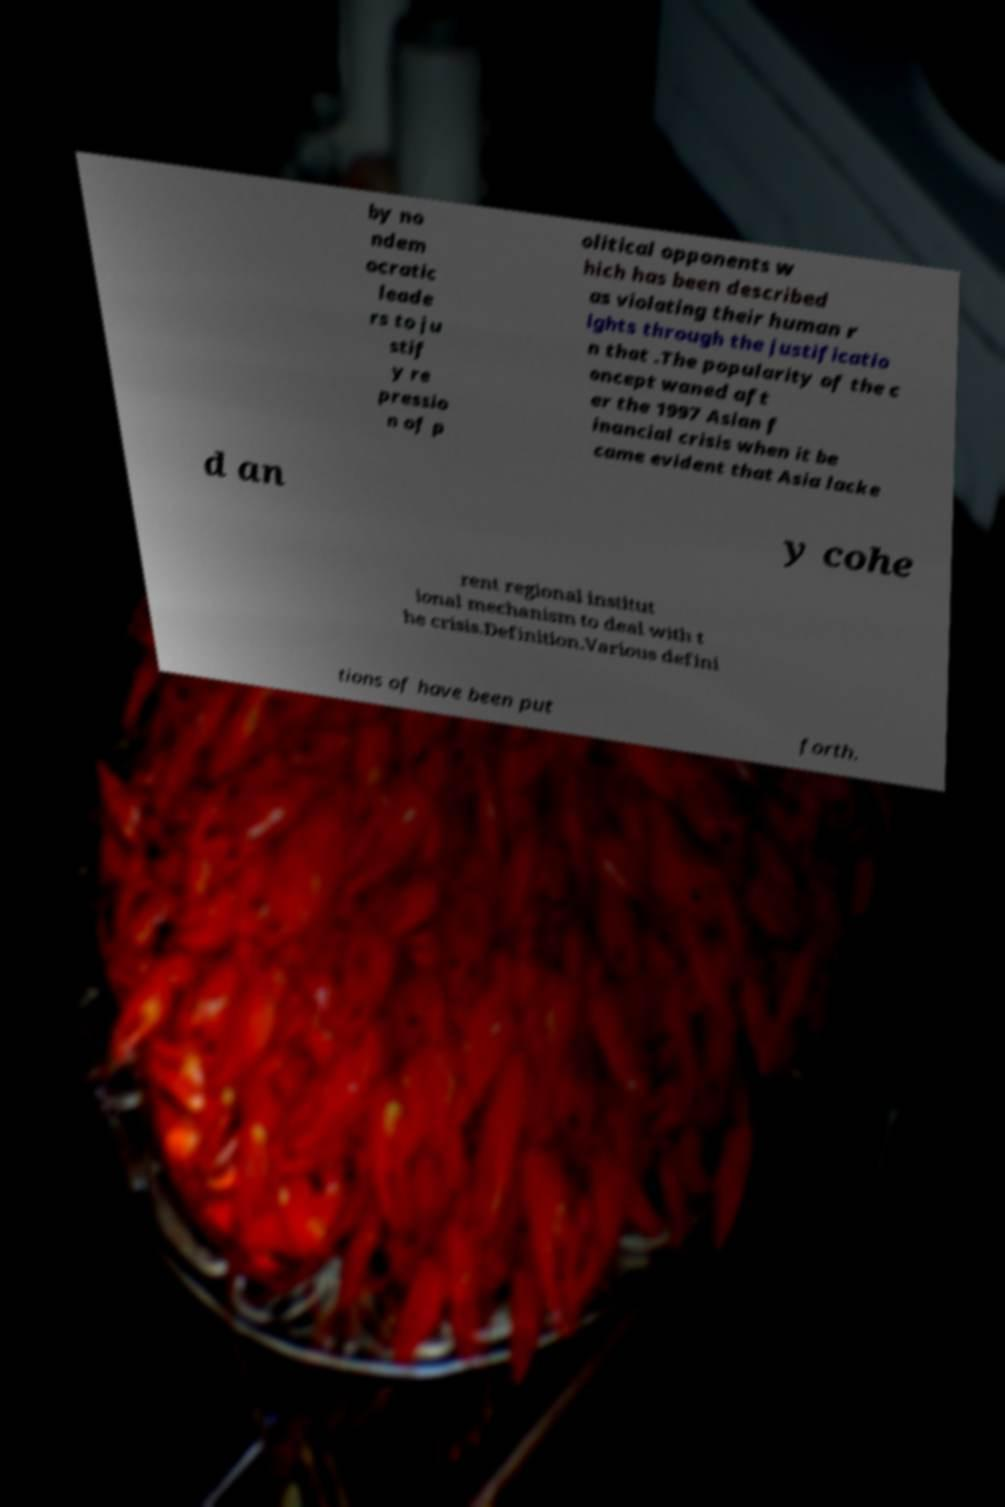For documentation purposes, I need the text within this image transcribed. Could you provide that? by no ndem ocratic leade rs to ju stif y re pressio n of p olitical opponents w hich has been described as violating their human r ights through the justificatio n that .The popularity of the c oncept waned aft er the 1997 Asian f inancial crisis when it be came evident that Asia lacke d an y cohe rent regional institut ional mechanism to deal with t he crisis.Definition.Various defini tions of have been put forth. 